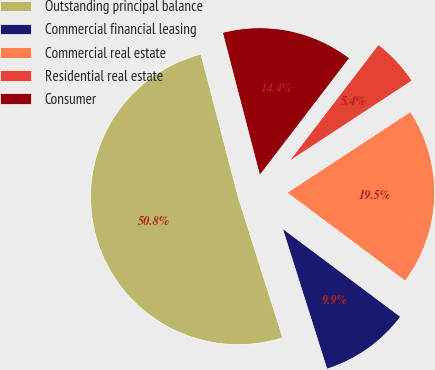Convert chart to OTSL. <chart><loc_0><loc_0><loc_500><loc_500><pie_chart><fcel>Outstanding principal balance<fcel>Commercial financial leasing<fcel>Commercial real estate<fcel>Residential real estate<fcel>Consumer<nl><fcel>50.82%<fcel>9.91%<fcel>19.46%<fcel>5.36%<fcel>14.45%<nl></chart> 